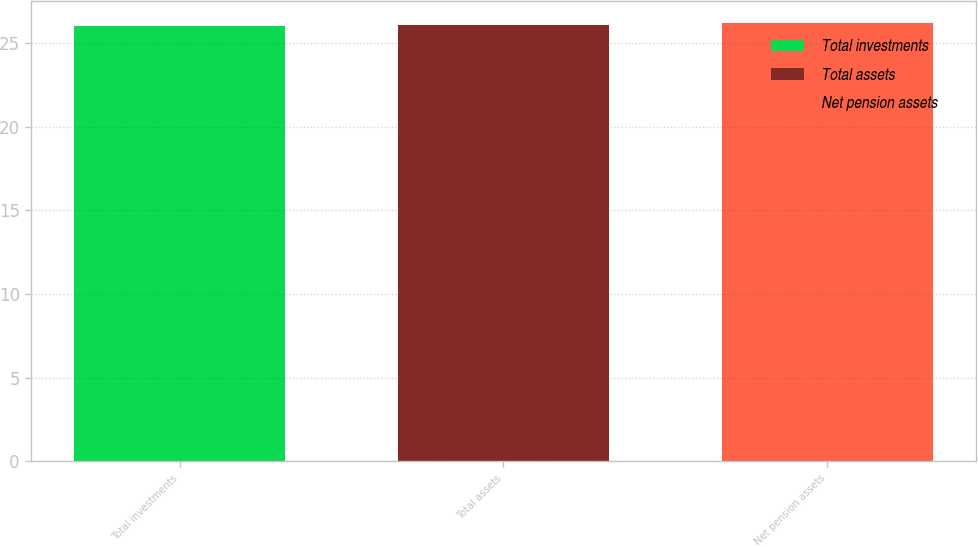<chart> <loc_0><loc_0><loc_500><loc_500><bar_chart><fcel>Total investments<fcel>Total assets<fcel>Net pension assets<nl><fcel>26<fcel>26.1<fcel>26.2<nl></chart> 